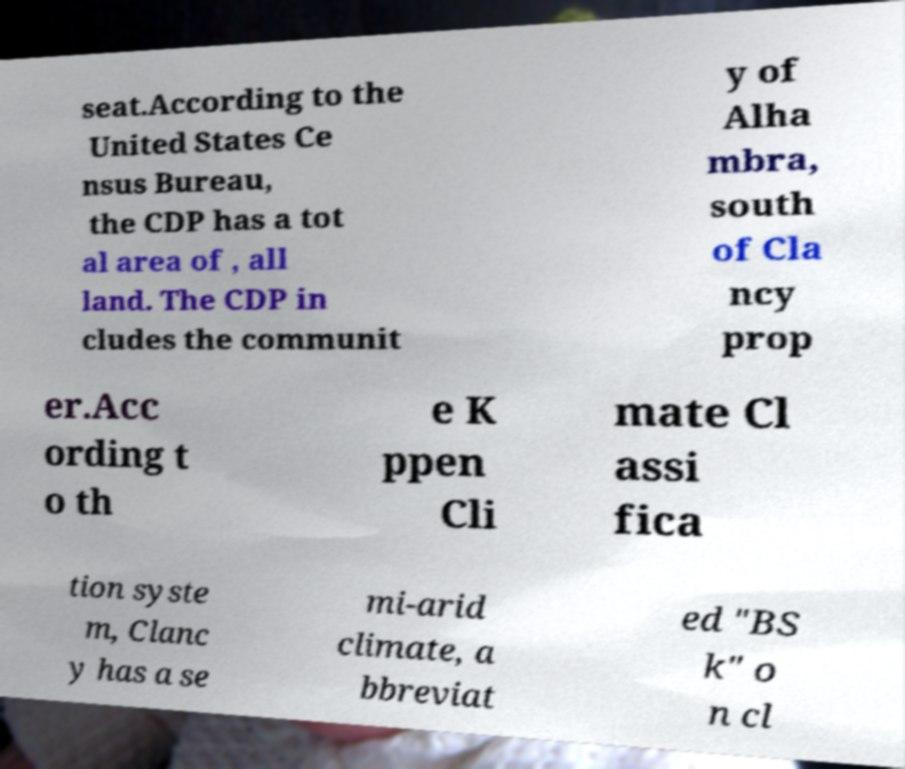Can you read and provide the text displayed in the image?This photo seems to have some interesting text. Can you extract and type it out for me? seat.According to the United States Ce nsus Bureau, the CDP has a tot al area of , all land. The CDP in cludes the communit y of Alha mbra, south of Cla ncy prop er.Acc ording t o th e K ppen Cli mate Cl assi fica tion syste m, Clanc y has a se mi-arid climate, a bbreviat ed "BS k" o n cl 